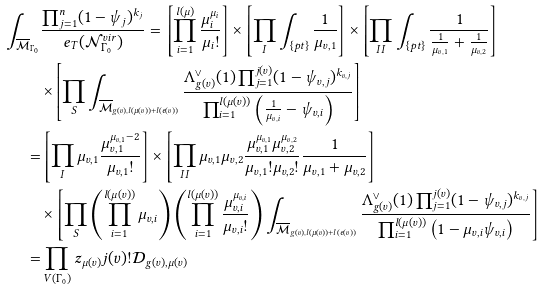<formula> <loc_0><loc_0><loc_500><loc_500>\int _ { \overline { \mathcal { M } } _ { \Gamma _ { 0 } } } & \frac { \prod _ { j = 1 } ^ { n } ( 1 - \psi _ { j } ) ^ { k _ { j } } } { e _ { T } ( \mathcal { N } _ { \Gamma _ { 0 } } ^ { v i r } ) } = \left [ \prod _ { i = 1 } ^ { l ( \mu ) } \frac { \mu _ { i } ^ { \mu _ { i } } } { \mu _ { i } ! } \right ] \times \left [ \prod _ { I } \int _ { \{ p t \} } \frac { 1 } { \mu _ { v , 1 } } \right ] \times \left [ \prod _ { I I } \int _ { \{ p t \} } \frac { 1 } { \frac { 1 } { \mu _ { v , 1 } } + \frac { 1 } { \mu _ { v , 2 } } } \right ] \\ & \times \left [ \prod _ { S } \int _ { \overline { \mathcal { M } } _ { g ( v ) , l ( \mu ( v ) ) + l ( e ( v ) ) } } \frac { \Lambda _ { g ( v ) } ^ { \vee } ( 1 ) \prod _ { j = 1 } ^ { j ( v ) } ( 1 - \psi _ { v , j } ) ^ { k _ { v , j } } } { \prod _ { i = 1 } ^ { l ( \mu ( v ) ) } \left ( \frac { 1 } { \mu _ { v , i } } - \psi _ { v , i } \right ) } \right ] \\ = & \left [ \prod _ { I } \mu _ { v , 1 } \frac { \mu _ { v , 1 } ^ { \mu _ { v , 1 } - 2 } } { \mu _ { v , 1 } ! } \right ] \times \left [ \prod _ { I I } \mu _ { v , 1 } \mu _ { v , 2 } \frac { \mu _ { v , 1 } ^ { \mu _ { v , 1 } } \mu _ { v , 2 } ^ { \mu _ { v , 2 } } } { \mu _ { v , 1 } ! \mu _ { v , 2 } ! } \frac { 1 } { \mu _ { v , 1 } + \mu _ { v , 2 } } \right ] \\ & \times \left [ \prod _ { S } \left ( \prod _ { i = 1 } ^ { l ( \mu ( v ) ) } \mu _ { v , i } \right ) \left ( \prod _ { i = 1 } ^ { l ( \mu ( v ) ) } \frac { \mu _ { v , i } ^ { \mu _ { v , i } } } { \mu _ { v , i } ! } \right ) \int _ { \overline { \mathcal { M } } _ { g ( v ) , l ( \mu ( v ) ) + l ( e ( v ) ) } } \frac { \Lambda _ { g ( v ) } ^ { \vee } ( 1 ) \prod _ { j = 1 } ^ { j ( v ) } ( 1 - \psi _ { v , j } ) ^ { k _ { v , j } } } { \prod _ { i = 1 } ^ { l ( \mu ( v ) ) } \left ( 1 - \mu _ { v , i } \psi _ { v , i } \right ) } \right ] \\ = & \prod _ { V ( \Gamma _ { 0 } ) } z _ { \mu ( v ) } j ( v ) ! \mathcal { D } _ { g ( v ) , \mu ( v ) }</formula> 